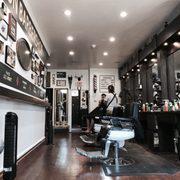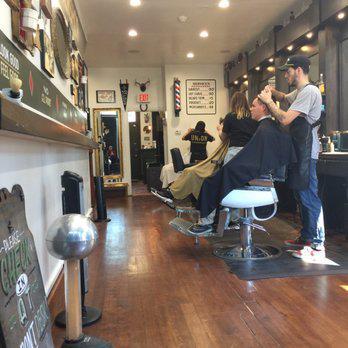The first image is the image on the left, the second image is the image on the right. For the images shown, is this caption "There are at least four people in the image on the right." true? Answer yes or no. Yes. 